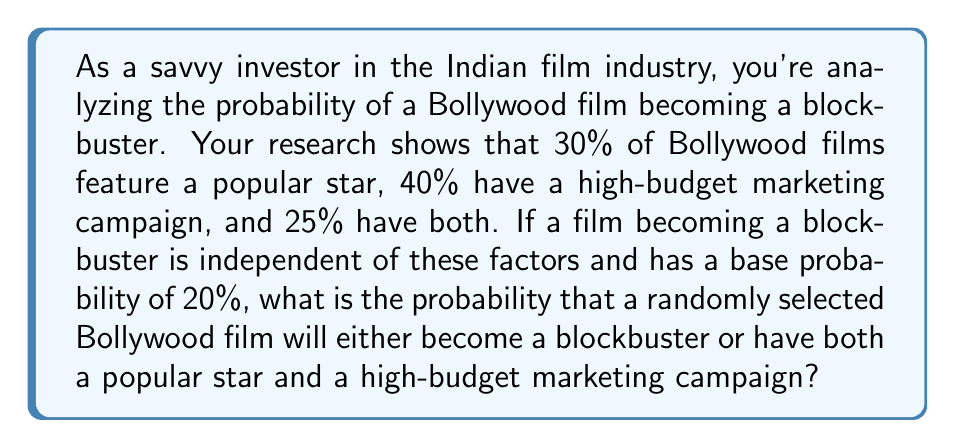Help me with this question. Let's approach this step-by-step using probability theory:

1) Define events:
   A: Film has a popular star
   B: Film has a high-budget marketing campaign
   C: Film becomes a blockbuster

2) Given probabilities:
   P(A) = 0.30
   P(B) = 0.40
   P(A ∩ B) = 0.25
   P(C) = 0.20

3) We need to find P(C ∪ (A ∩ B)). We can use the addition rule of probability:

   P(C ∪ (A ∩ B)) = P(C) + P(A ∩ B) - P(C ∩ (A ∩ B))

4) We already know P(C) and P(A ∩ B). We need to find P(C ∩ (A ∩ B)).

5) Since C is independent of A and B, we can say:
   P(C ∩ (A ∩ B)) = P(C) × P(A ∩ B) = 0.20 × 0.25 = 0.05

6) Now we can substitute into our equation:

   P(C ∪ (A ∩ B)) = 0.20 + 0.25 - 0.05 = 0.40

Therefore, the probability is 0.40 or 40%.
Answer: 0.40 